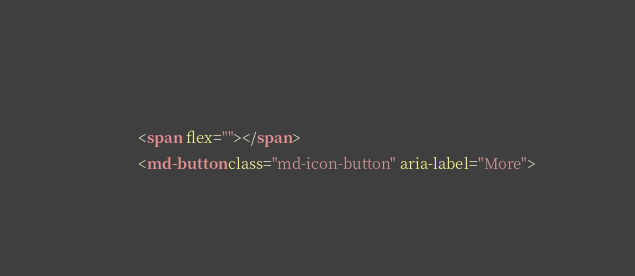<code> <loc_0><loc_0><loc_500><loc_500><_HTML_>          
          <span flex=""></span>
          <md-button class="md-icon-button" aria-label="More"></code> 